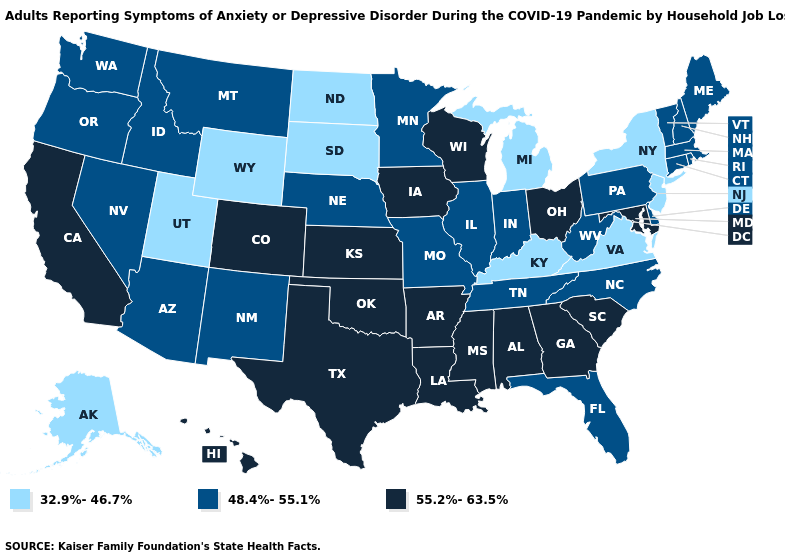Does Illinois have a higher value than Massachusetts?
Answer briefly. No. Name the states that have a value in the range 48.4%-55.1%?
Answer briefly. Arizona, Connecticut, Delaware, Florida, Idaho, Illinois, Indiana, Maine, Massachusetts, Minnesota, Missouri, Montana, Nebraska, Nevada, New Hampshire, New Mexico, North Carolina, Oregon, Pennsylvania, Rhode Island, Tennessee, Vermont, Washington, West Virginia. What is the value of Washington?
Concise answer only. 48.4%-55.1%. What is the lowest value in states that border Minnesota?
Answer briefly. 32.9%-46.7%. What is the value of Oregon?
Answer briefly. 48.4%-55.1%. Among the states that border Kentucky , which have the lowest value?
Answer briefly. Virginia. Among the states that border Montana , which have the highest value?
Short answer required. Idaho. Among the states that border South Dakota , which have the highest value?
Give a very brief answer. Iowa. Name the states that have a value in the range 55.2%-63.5%?
Answer briefly. Alabama, Arkansas, California, Colorado, Georgia, Hawaii, Iowa, Kansas, Louisiana, Maryland, Mississippi, Ohio, Oklahoma, South Carolina, Texas, Wisconsin. Which states have the highest value in the USA?
Write a very short answer. Alabama, Arkansas, California, Colorado, Georgia, Hawaii, Iowa, Kansas, Louisiana, Maryland, Mississippi, Ohio, Oklahoma, South Carolina, Texas, Wisconsin. Does Oregon have a lower value than Arkansas?
Quick response, please. Yes. Does Delaware have the same value as Oregon?
Answer briefly. Yes. Name the states that have a value in the range 32.9%-46.7%?
Concise answer only. Alaska, Kentucky, Michigan, New Jersey, New York, North Dakota, South Dakota, Utah, Virginia, Wyoming. Does the map have missing data?
Concise answer only. No. What is the highest value in the USA?
Answer briefly. 55.2%-63.5%. 